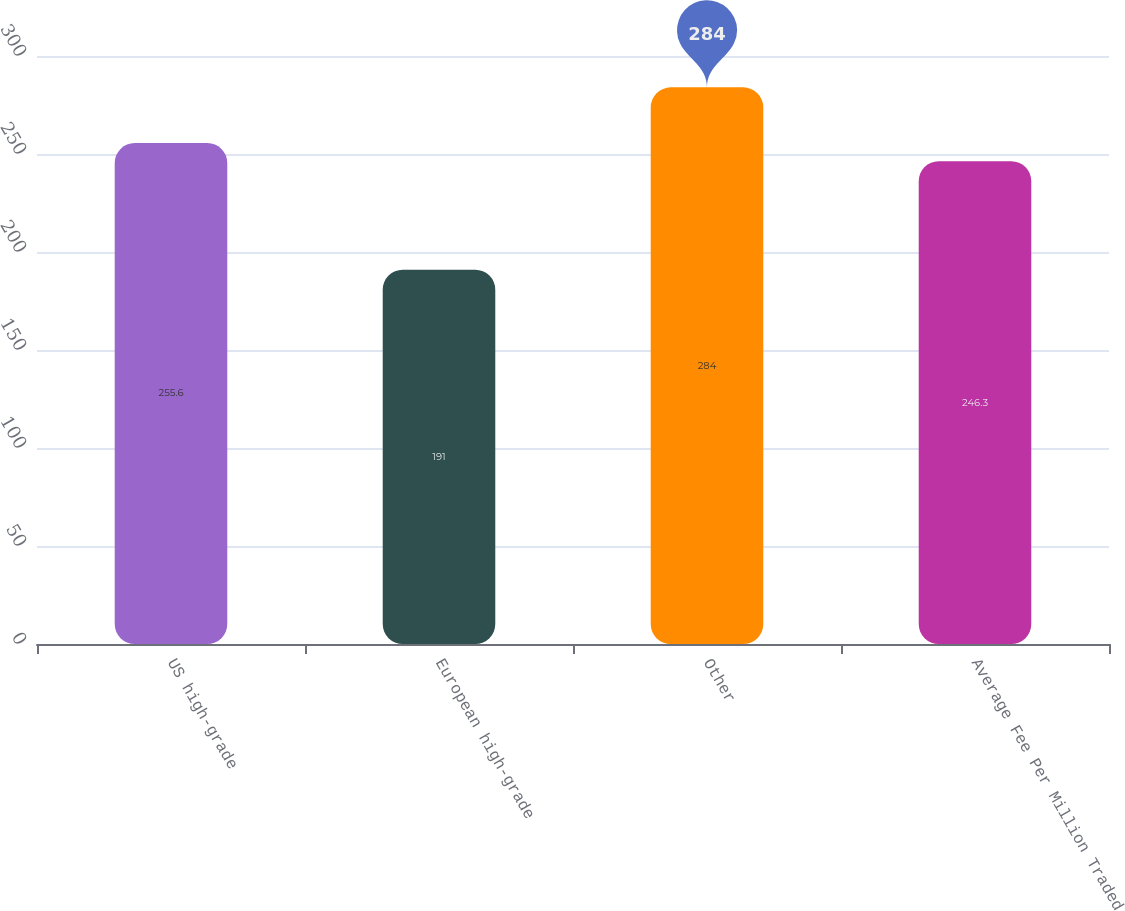Convert chart. <chart><loc_0><loc_0><loc_500><loc_500><bar_chart><fcel>US high-grade<fcel>European high-grade<fcel>Other<fcel>Average Fee Per Million Traded<nl><fcel>255.6<fcel>191<fcel>284<fcel>246.3<nl></chart> 